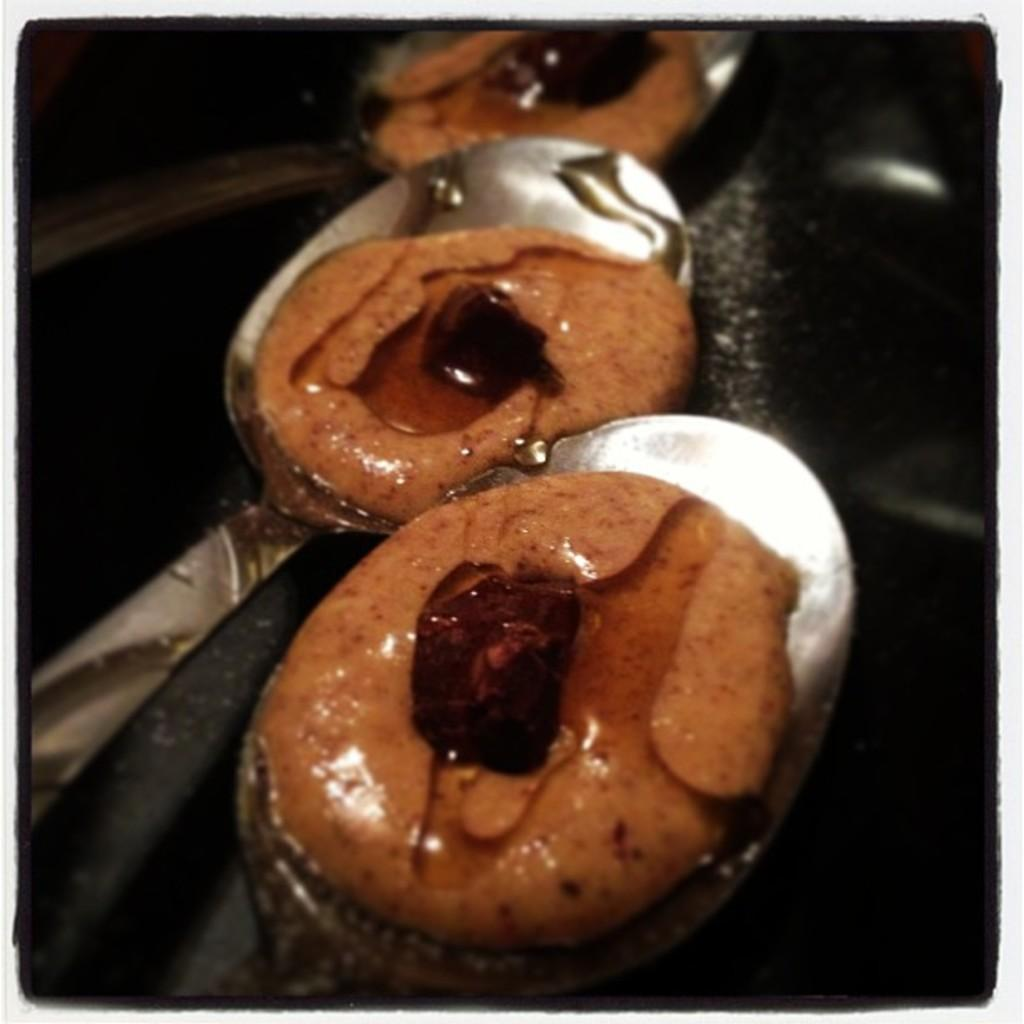How many spoons are visible in the image? There are three spoons in the image. What else can be seen in the image besides the spoons? There are three sweets in the image. What type of stamp is being used to hold the sweets in the image? There is no stamp present in the image; the sweets are not being held by any object. What action is the thumb performing in the image? There is no thumb or any action involving a thumb present in the image. 